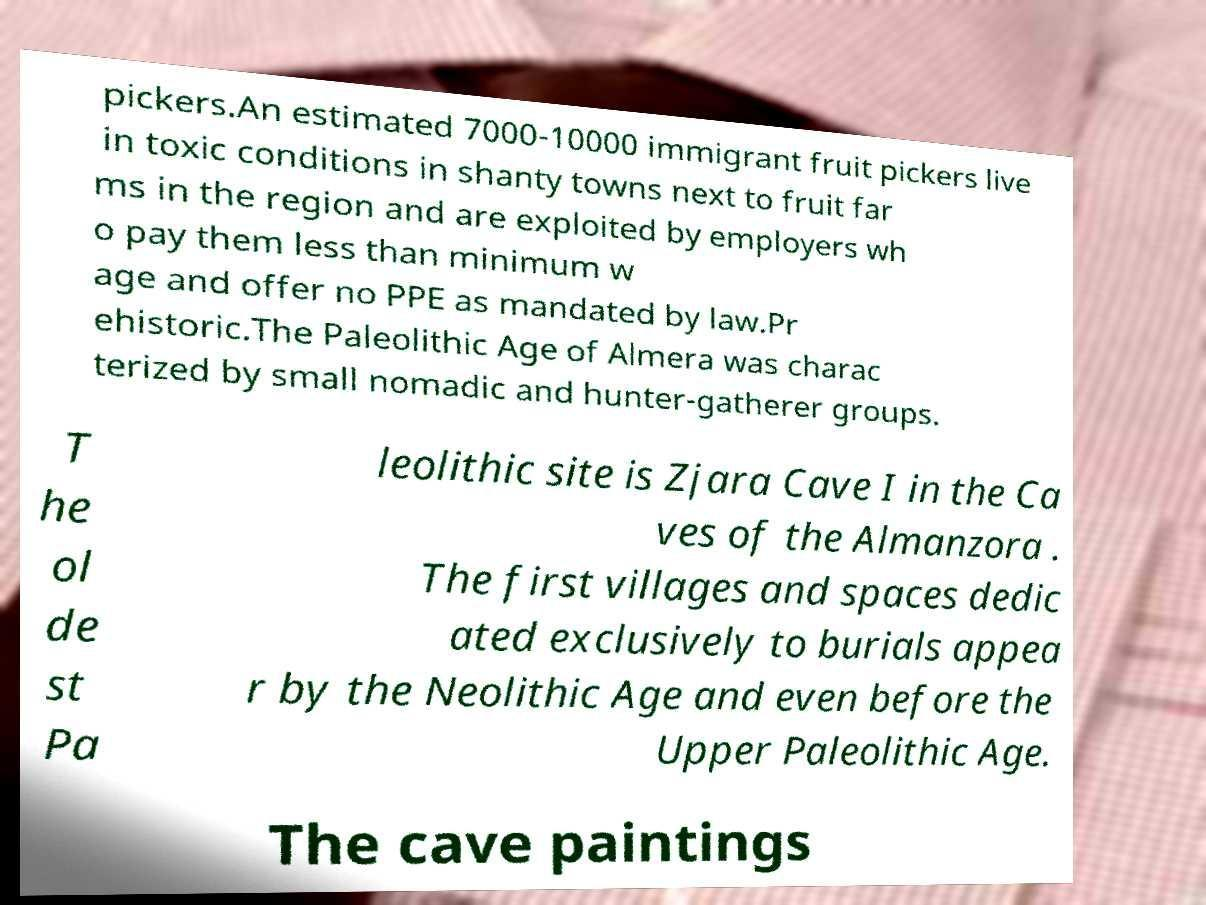I need the written content from this picture converted into text. Can you do that? pickers.An estimated 7000-10000 immigrant fruit pickers live in toxic conditions in shanty towns next to fruit far ms in the region and are exploited by employers wh o pay them less than minimum w age and offer no PPE as mandated by law.Pr ehistoric.The Paleolithic Age of Almera was charac terized by small nomadic and hunter-gatherer groups. T he ol de st Pa leolithic site is Zjara Cave I in the Ca ves of the Almanzora . The first villages and spaces dedic ated exclusively to burials appea r by the Neolithic Age and even before the Upper Paleolithic Age. The cave paintings 